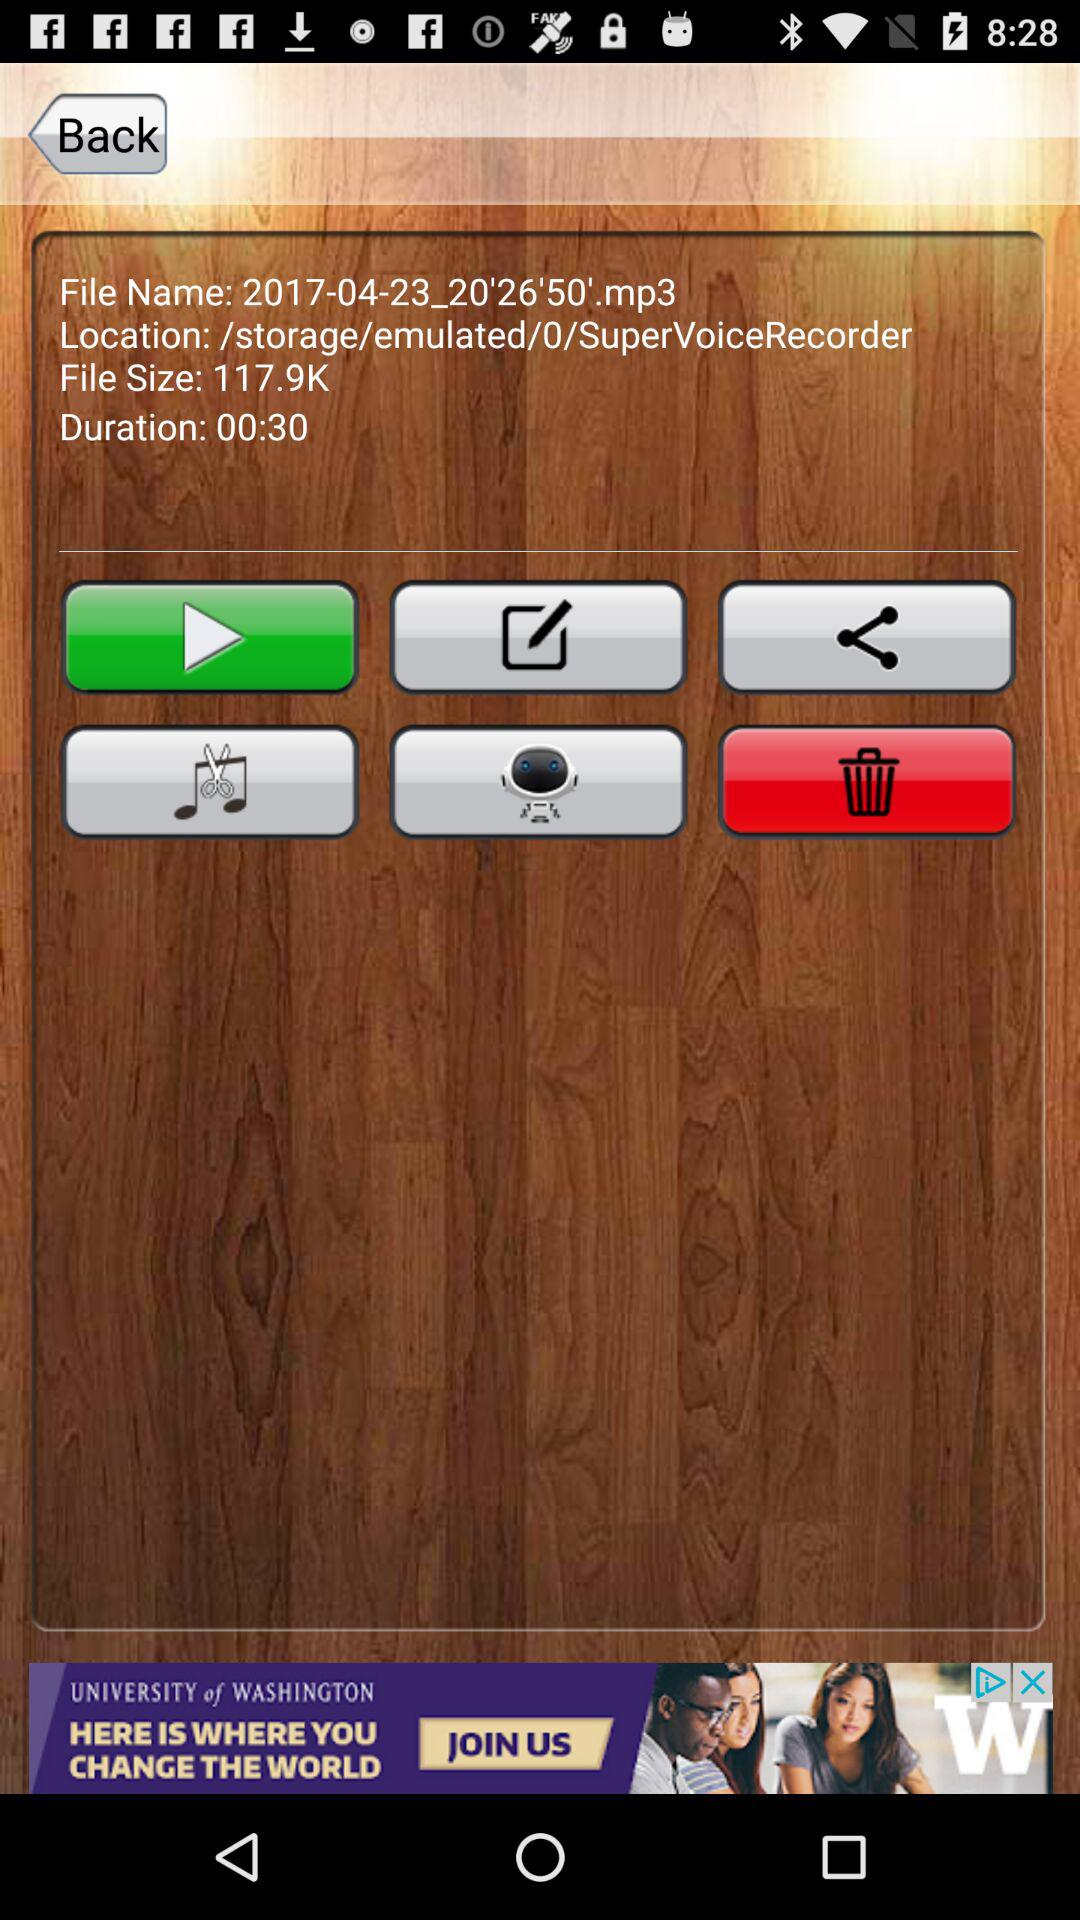What is the file size? The file size is 117.9K. 